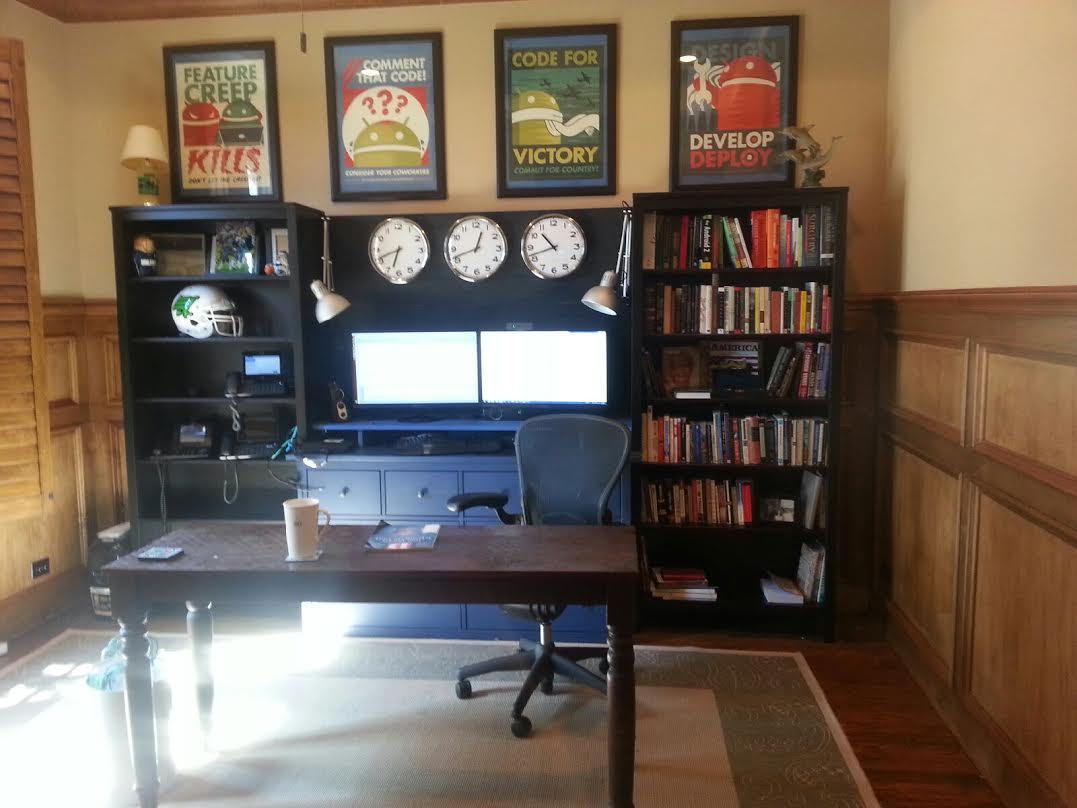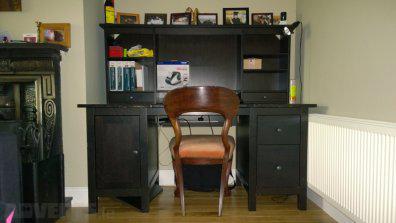The first image is the image on the left, the second image is the image on the right. For the images shown, is this caption "One image features a traditional desk up against a wall, with a hutch on top of the desk, a one-door cabinet underneath on the left, and two drawers on the right." true? Answer yes or no. Yes. The first image is the image on the left, the second image is the image on the right. Examine the images to the left and right. Is the description "There is a desk in each image." accurate? Answer yes or no. Yes. 